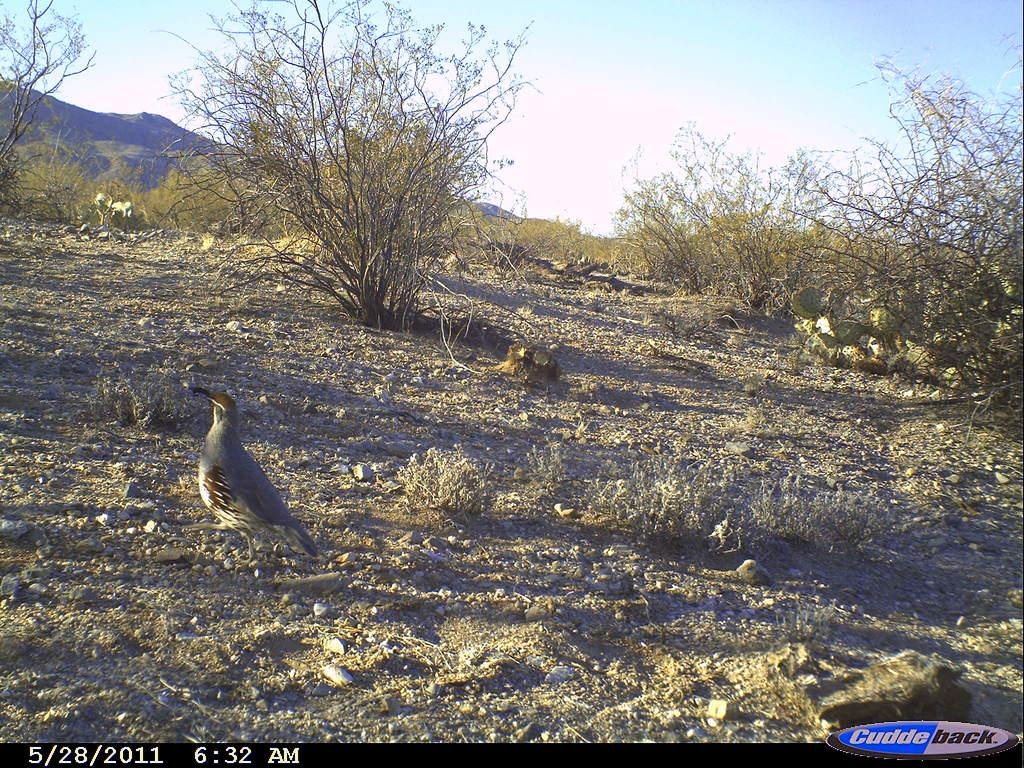What type of animal can be seen in the image? There is a bird in the image. Where is the bird located in the image? The bird is on a slope area. What can be seen in the background of the image? There are plants, a mountain, and the sky visible in the background of the image. What additional information is provided at the bottom of the image? There is a date, time, and a logo at the bottom of the image. How many boats are visible in the image? There are no boats present in the image. What type of fruit is the bird holding in its beak? The bird is not holding any fruit in its beak, as there are no fruits visible in the image. 